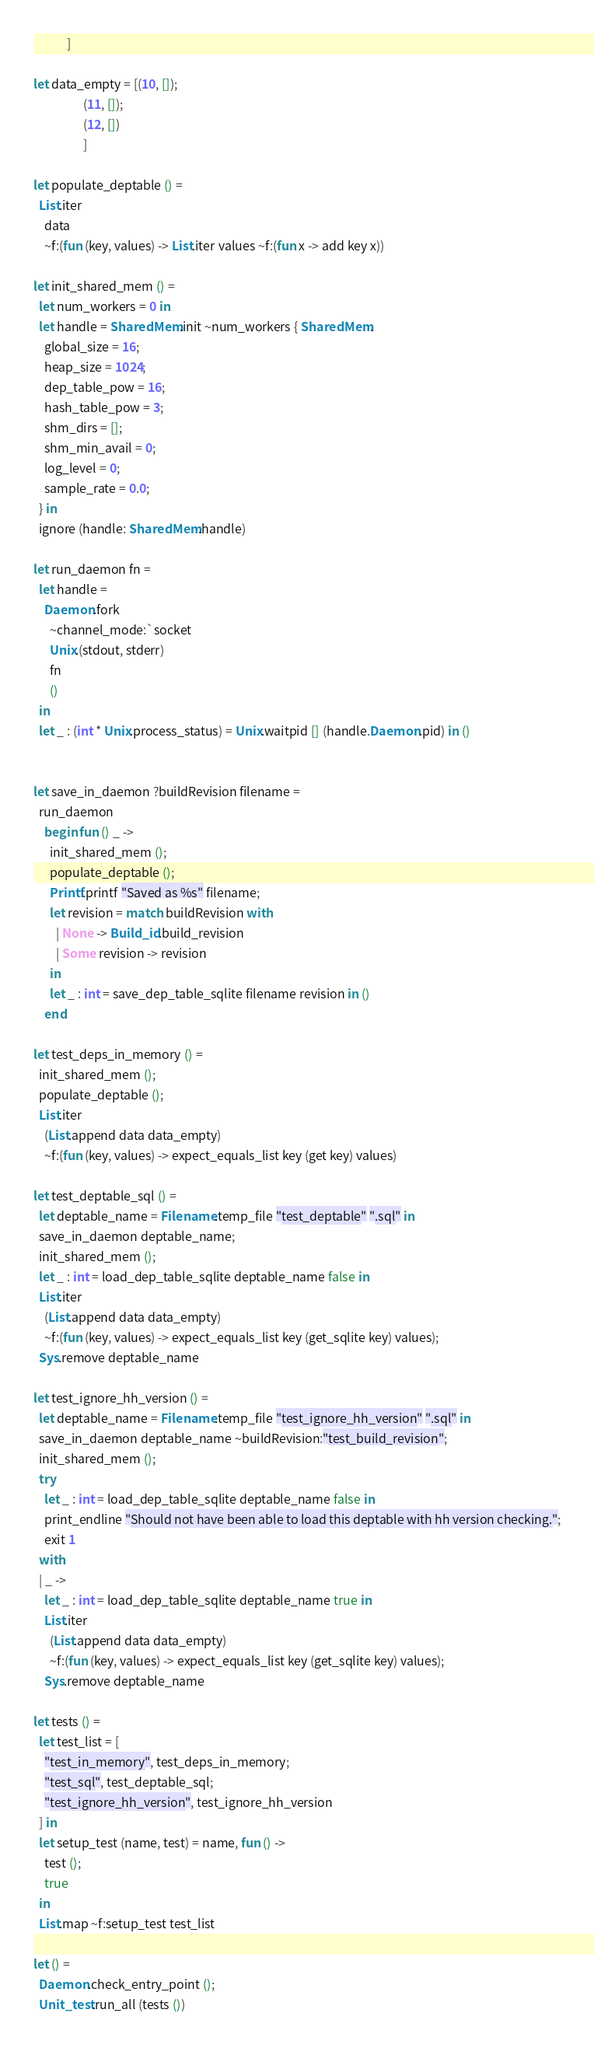<code> <loc_0><loc_0><loc_500><loc_500><_OCaml_>            ]

let data_empty = [(10, []);
                  (11, []);
                  (12, [])
                  ]

let populate_deptable () =
  List.iter
    data
    ~f:(fun (key, values) -> List.iter values ~f:(fun x -> add key x))

let init_shared_mem () =
  let num_workers = 0 in
  let handle = SharedMem.init ~num_workers { SharedMem.
    global_size = 16;
    heap_size = 1024;
    dep_table_pow = 16;
    hash_table_pow = 3;
    shm_dirs = [];
    shm_min_avail = 0;
    log_level = 0;
    sample_rate = 0.0;
  } in
  ignore (handle: SharedMem.handle)

let run_daemon fn =
  let handle =
    Daemon.fork
      ~channel_mode:`socket
      Unix.(stdout, stderr)
      fn
      ()
  in
  let _ : (int * Unix.process_status) = Unix.waitpid [] (handle.Daemon.pid) in ()


let save_in_daemon ?buildRevision filename =
  run_daemon
    begin fun () _ ->
      init_shared_mem ();
      populate_deptable ();
      Printf.printf "Saved as %s" filename;
      let revision = match buildRevision with
        | None -> Build_id.build_revision
        | Some revision -> revision
      in
      let _ : int = save_dep_table_sqlite filename revision in ()
    end

let test_deps_in_memory () =
  init_shared_mem ();
  populate_deptable ();
  List.iter
    (List.append data data_empty)
    ~f:(fun (key, values) -> expect_equals_list key (get key) values)

let test_deptable_sql () =
  let deptable_name = Filename.temp_file "test_deptable" ".sql" in
  save_in_daemon deptable_name;
  init_shared_mem ();
  let _ : int = load_dep_table_sqlite deptable_name false in
  List.iter
    (List.append data data_empty)
    ~f:(fun (key, values) -> expect_equals_list key (get_sqlite key) values);
  Sys.remove deptable_name

let test_ignore_hh_version () =
  let deptable_name = Filename.temp_file "test_ignore_hh_version" ".sql" in
  save_in_daemon deptable_name ~buildRevision:"test_build_revision";
  init_shared_mem ();
  try
    let _ : int = load_dep_table_sqlite deptable_name false in
    print_endline "Should not have been able to load this deptable with hh version checking.";
    exit 1
  with
  | _ ->
    let _ : int = load_dep_table_sqlite deptable_name true in
    List.iter
      (List.append data data_empty)
      ~f:(fun (key, values) -> expect_equals_list key (get_sqlite key) values);
    Sys.remove deptable_name

let tests () =
  let test_list = [
    "test_in_memory", test_deps_in_memory;
    "test_sql", test_deptable_sql;
    "test_ignore_hh_version", test_ignore_hh_version
  ] in
  let setup_test (name, test) = name, fun () ->
    test ();
    true
  in
  List.map ~f:setup_test test_list

let () =
  Daemon.check_entry_point ();
  Unit_test.run_all (tests ())
</code> 